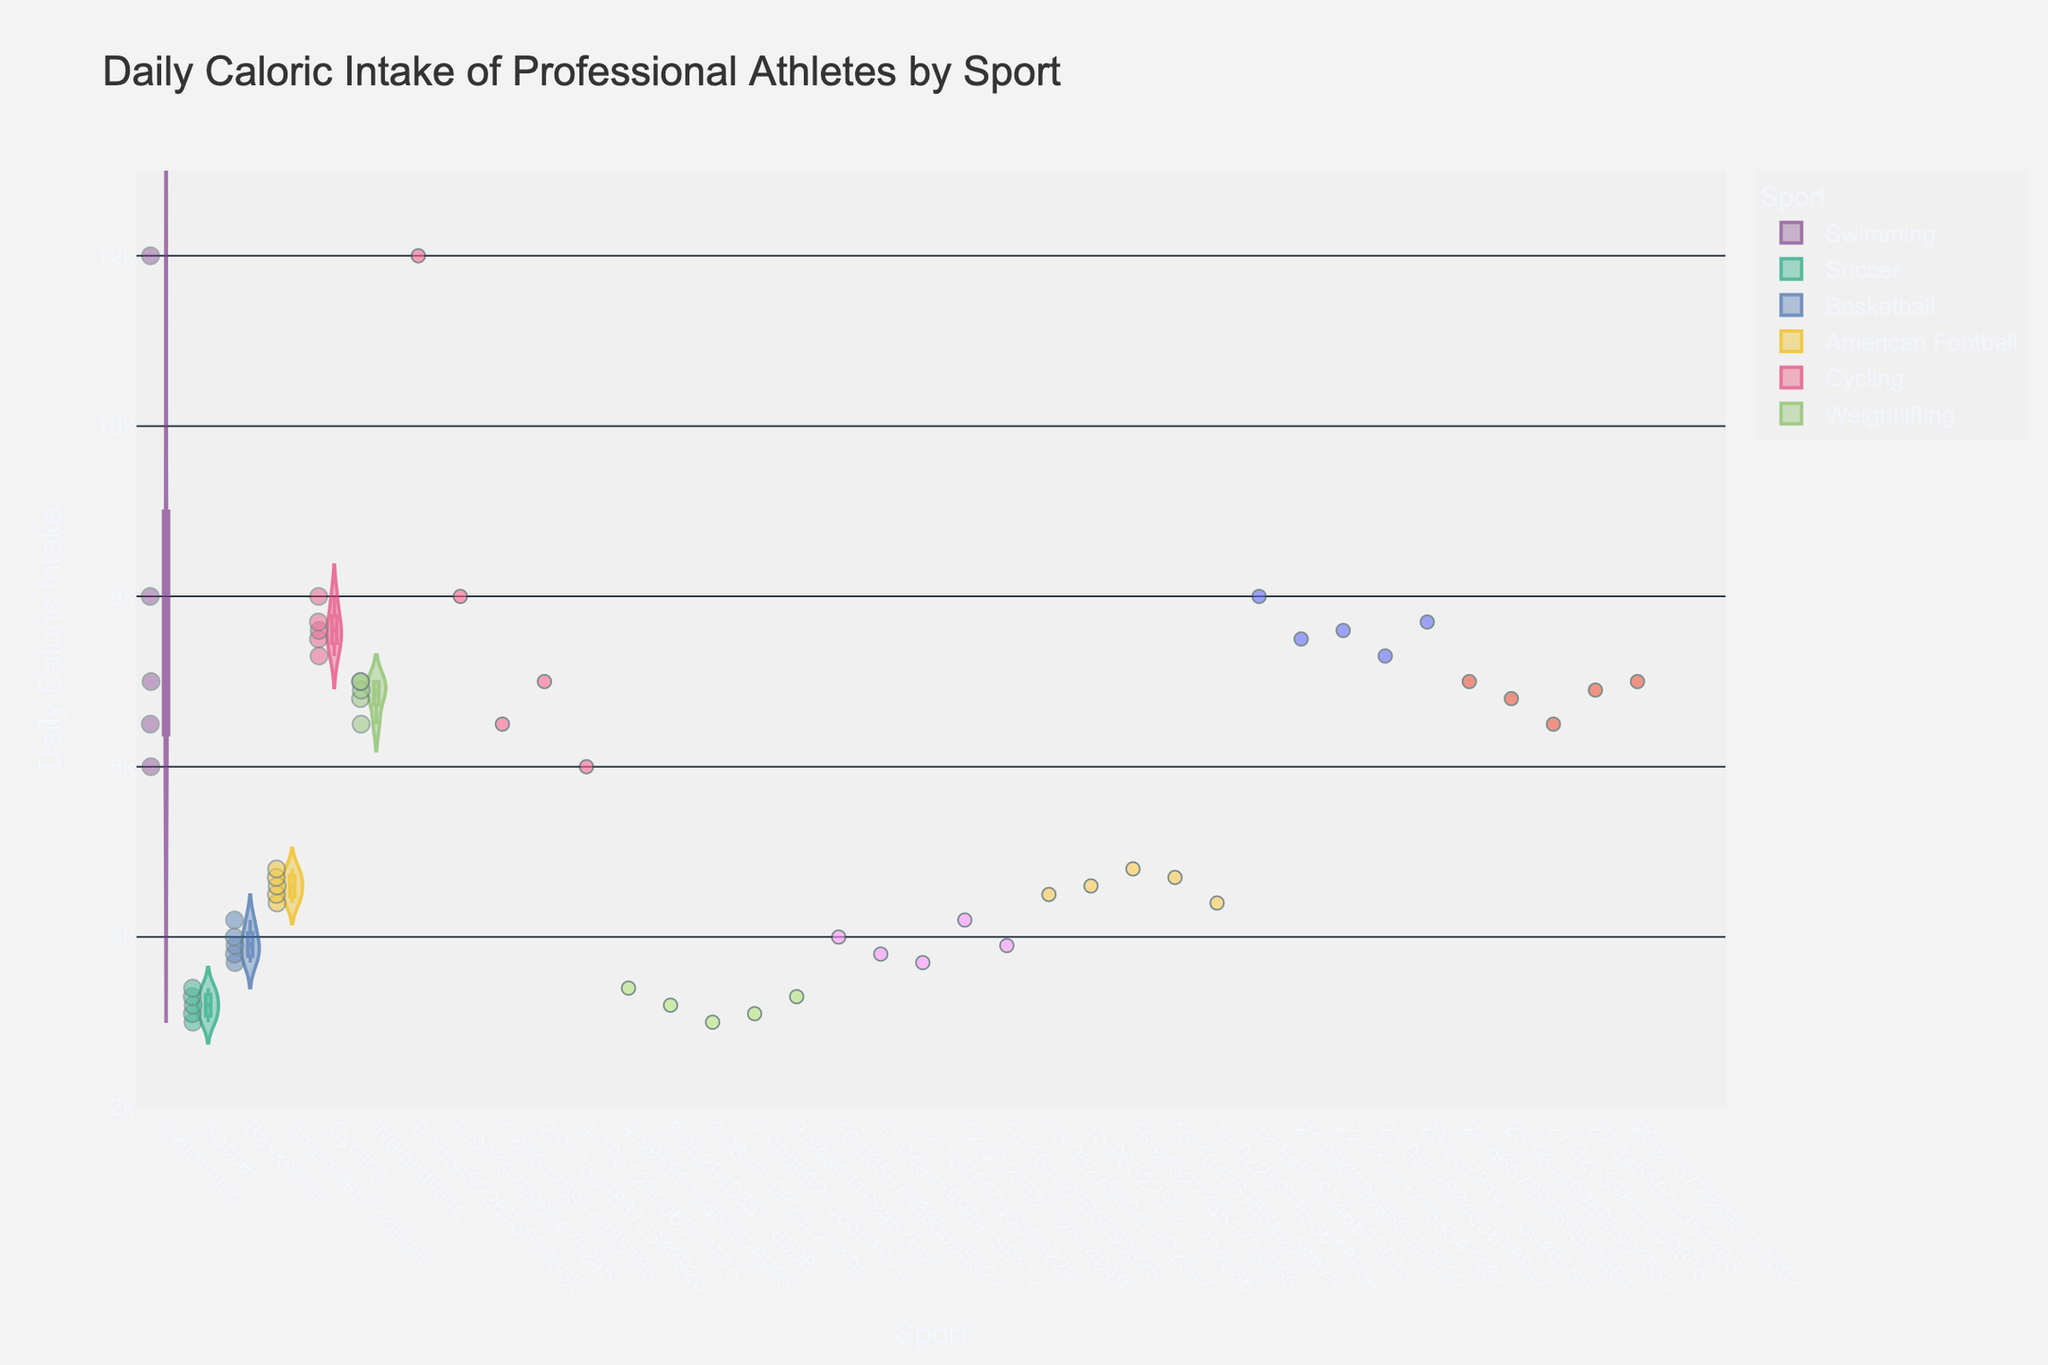How many sports are displayed in the figure? The x-axis shows distinct categories for different sports. By counting these categories, you can determine the number of sports displayed.
Answer: 6 Which sport has the highest median caloric intake? The box inside each violin plot represents the interquartile range, and the line in the middle of the box represents the median. By observing these medians, you can find the sport with the highest median caloric intake.
Answer: Swimming What is the range of daily caloric intakes for cycling athletes? The y-axis displays the range of caloric intake values. The width of the violin plot within this sport's category shows the distribution, and the box plot inside it provides the interquartile range. Observing the spread of points and the violin plot itself will give the range.
Answer: 7300 to 8000 Which athlete has the highest daily caloric intake and what sport do they play? Hovering or observing the highest data point on the y-axis allows identification of the specific athlete and their sport.
Answer: Michael Phelps, Swimming Is the caloric intake for American football players generally higher or lower compared to soccer players? By comparing the position and spread of the points and medians for American football and soccer categories on the y-axis, you can assess if one is generally higher or lower than the other.
Answer: Higher Which sport has the least variation in caloric intake among its athletes? The sport with the smallest spread in data points and the narrowest violin plot indicates the least variation among athletes.
Answer: Soccer What is the approximate mean caloric intake for basketball players? The mean line in the middle of the violin plot for basketball indicates the average caloric intake. Observing this line within the basketball category will provide the answer.
Answer: Approximately 3920 By how much does the highest caloric intake differ from the lowest caloric intake among the displayed athletes? Observing the highest and lowest points on the y-axis and calculating the difference between these values will provide the answer.
Answer: 12000 - 3000 = 9000 Are there more athletes with caloric intakes above 6000 or below 6000? Counting the jittered points displayed above and below the 6000 mark on the y-axis provides the number of athletes in each range.
Answer: Above 6000 